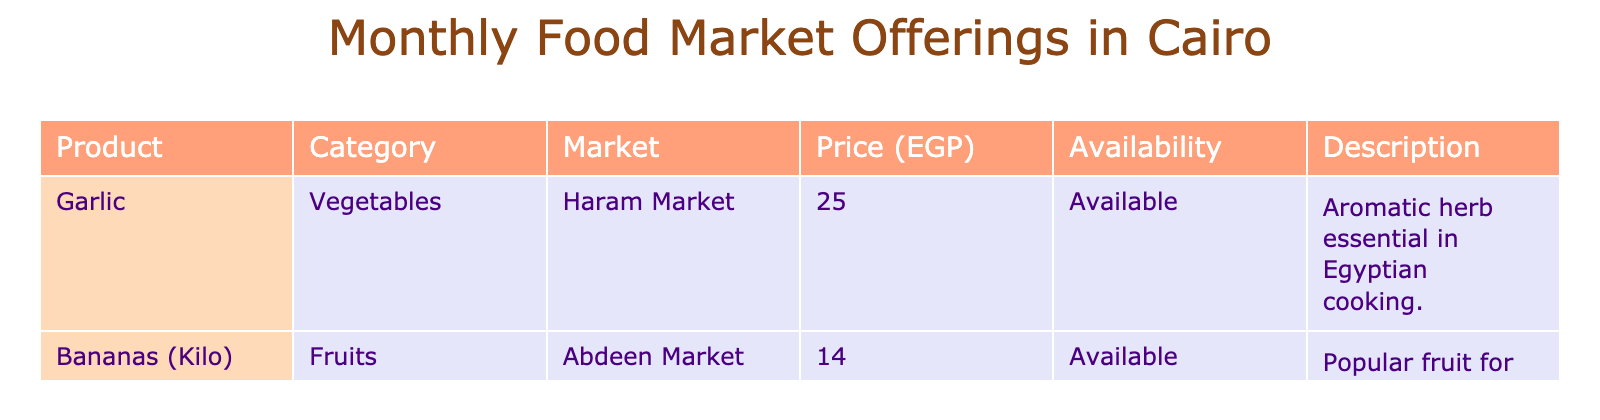What is the price of garlic at the Haram Market? The table lists garlic under the product category, and the corresponding price at the Haram Market is shown as 25 EGP.
Answer: 25 EGP Which market offers bananas? Referring to the table, bananas are listed under the Abdeen Market.
Answer: Abdeen Market What is the total price of garlic and bananas combined? To find the total, add the price of garlic (25 EGP) and the price of bananas (14 EGP): 25 + 14 = 39 EGP.
Answer: 39 EGP Is garlic available in the market? The table states that garlic is marked as "Available" in its availability column.
Answer: Yes Which product has a lower price: garlic or bananas? The price for garlic is 25 EGP, while bananas are priced at 14 EGP. Since 14 is less than 25, bananas are cheaper.
Answer: Bananas What is the average price of the products listed in the table? There are two products with prices of 25 EGP (garlic) and 14 EGP (bananas). To find the average, sum the prices (25 + 14 = 39) and divide by the number of products (2): 39 / 2 = 19.5.
Answer: 19.5 EGP Do fruits or vegetables have higher average prices in this table? Calculate the average price of vegetables (only garlic at 25 EGP) and fruits (only bananas at 14 EGP). The average for vegetables is 25 EGP and for fruits is 14 EGP. Since 25 EGP is greater than 14 EGP, vegetables are more expensive.
Answer: Vegetables How many products are listed in the table? The table shows two products: garlic and bananas. Counting these gives a total of 2 products.
Answer: 2 products Which market has the highest priced item, and what is that price? Evaluating the prices from the table, we have garlic at 25 EGP in the Haram Market and bananas at 14 EGP in the Abdeen Market. The highest price is 25 EGP for garlic at the Haram Market.
Answer: Haram Market, 25 EGP Are all items in the table available? Both items listed (garlic and bananas) have "Available" noted under their availability status, indicating they are both available.
Answer: Yes 